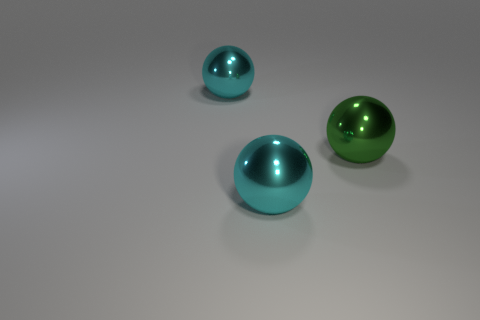What number of tiny things are cyan metallic things or green balls?
Give a very brief answer. 0. What material is the ball that is in front of the large green object behind the cyan sphere in front of the big green metal ball?
Offer a very short reply. Metal. How many metal objects are either green blocks or big cyan things?
Offer a very short reply. 2. How many blue objects are either big metallic things or tiny cylinders?
Ensure brevity in your answer.  0. There is a big green metal thing that is to the right of the large cyan sphere to the left of the big metal object in front of the green metal thing; what is its shape?
Give a very brief answer. Sphere. Is the number of objects to the left of the green metallic object greater than the number of large cyan cylinders?
Your response must be concise. Yes. Does the large shiny object that is in front of the green metallic ball have the same shape as the green metal thing?
Offer a terse response. Yes. What is the material of the large cyan thing behind the green ball?
Your answer should be compact. Metal. What number of other big metal things have the same shape as the big green thing?
Provide a short and direct response. 2. There is a sphere left of the shiny object in front of the large green shiny thing; what is its material?
Ensure brevity in your answer.  Metal. 